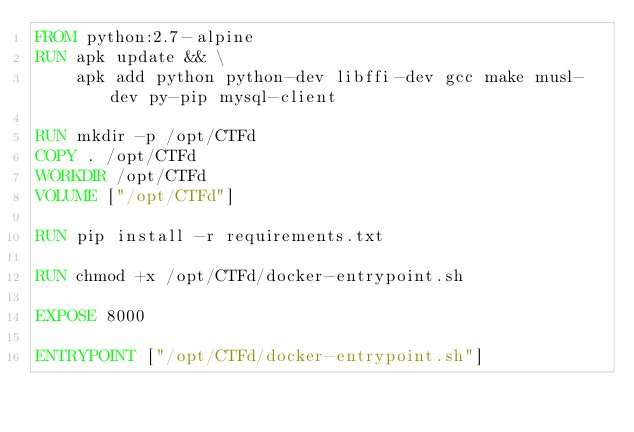Convert code to text. <code><loc_0><loc_0><loc_500><loc_500><_Dockerfile_>FROM python:2.7-alpine
RUN apk update && \
    apk add python python-dev libffi-dev gcc make musl-dev py-pip mysql-client

RUN mkdir -p /opt/CTFd
COPY . /opt/CTFd
WORKDIR /opt/CTFd
VOLUME ["/opt/CTFd"]

RUN pip install -r requirements.txt

RUN chmod +x /opt/CTFd/docker-entrypoint.sh

EXPOSE 8000

ENTRYPOINT ["/opt/CTFd/docker-entrypoint.sh"]
</code> 